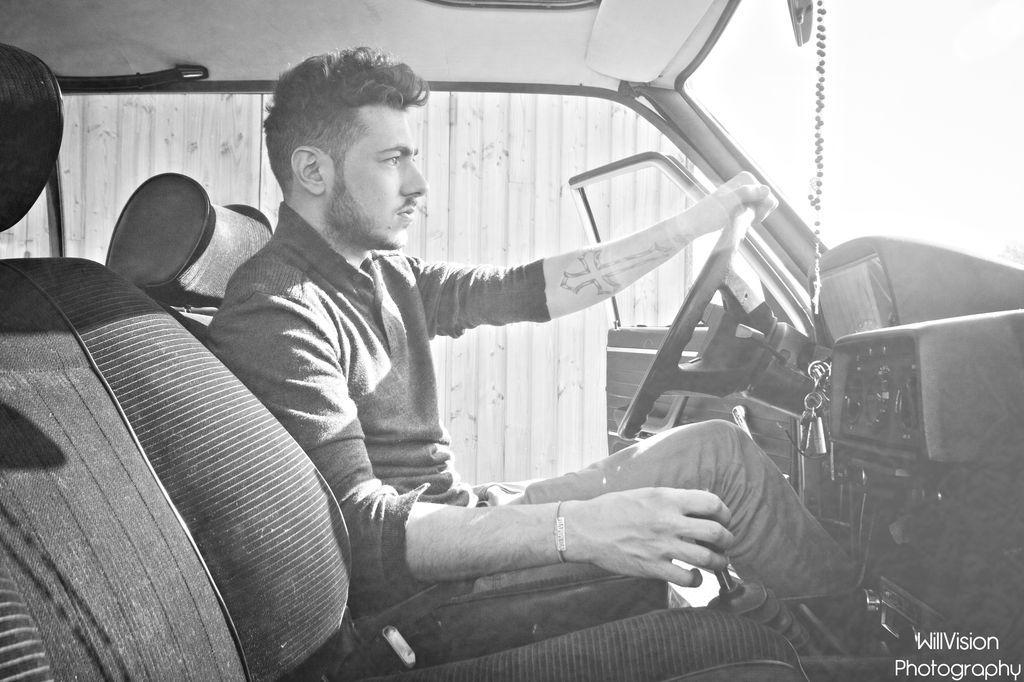Who is present in the image? There is a man in the image. What is the man holding in the image? The man is holding a steering wheel. Where is the man located in the image? The man is sitting inside a vehicle. What can be seen in the background of the image? There is a wall visible in the background of the image. What type of lunchroom game is the man playing in the image? There is no lunchroom game present in the image; the man is holding a steering wheel while sitting inside a vehicle. 